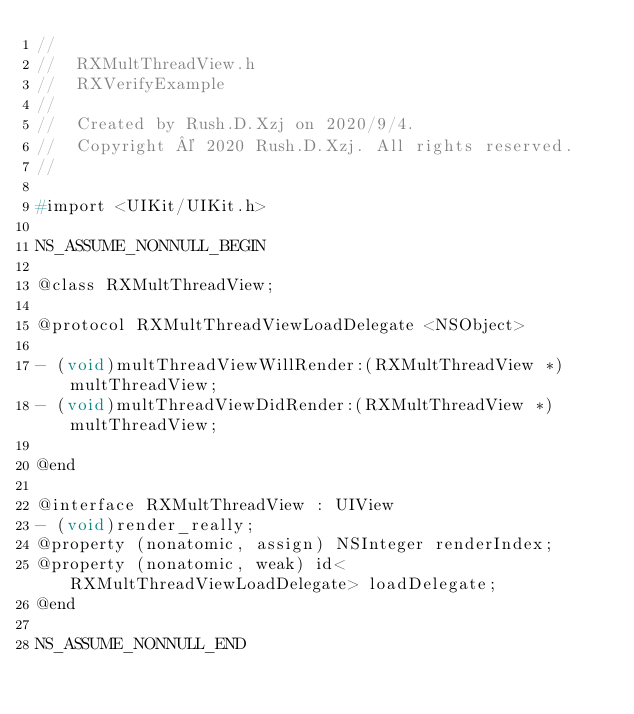Convert code to text. <code><loc_0><loc_0><loc_500><loc_500><_C_>//
//  RXMultThreadView.h
//  RXVerifyExample
//
//  Created by Rush.D.Xzj on 2020/9/4.
//  Copyright © 2020 Rush.D.Xzj. All rights reserved.
//

#import <UIKit/UIKit.h>

NS_ASSUME_NONNULL_BEGIN

@class RXMultThreadView;

@protocol RXMultThreadViewLoadDelegate <NSObject>

- (void)multThreadViewWillRender:(RXMultThreadView *)multThreadView;
- (void)multThreadViewDidRender:(RXMultThreadView *)multThreadView;

@end

@interface RXMultThreadView : UIView
- (void)render_really;
@property (nonatomic, assign) NSInteger renderIndex;
@property (nonatomic, weak) id<RXMultThreadViewLoadDelegate> loadDelegate;
@end

NS_ASSUME_NONNULL_END
</code> 